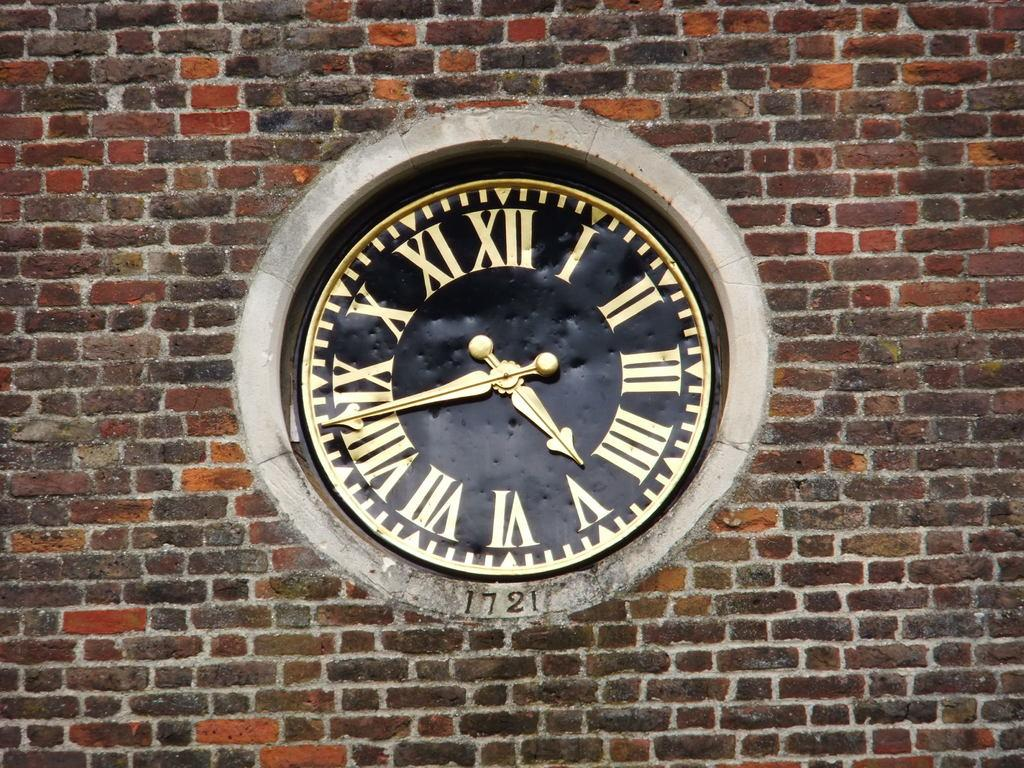<image>
Provide a brief description of the given image. A black and gold clock surrounded by a brick wall with roman numerals as numbers. 